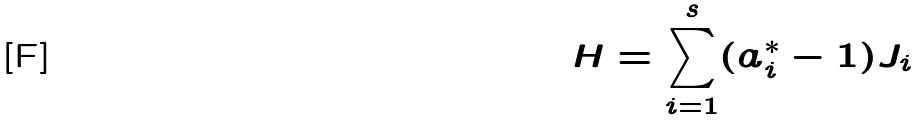<formula> <loc_0><loc_0><loc_500><loc_500>H = \sum _ { i = 1 } ^ { s } ( a _ { i } ^ { * } - 1 ) J _ { i }</formula> 